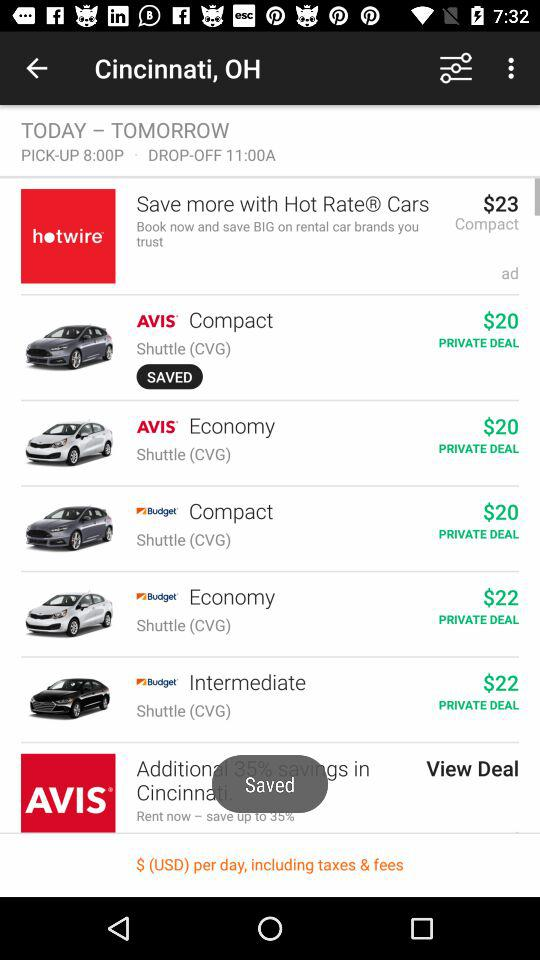What is the private deal price for the "Avis" Compact Shuttle? The private deal price for the "Avis" Compact Shuttle is $20. 